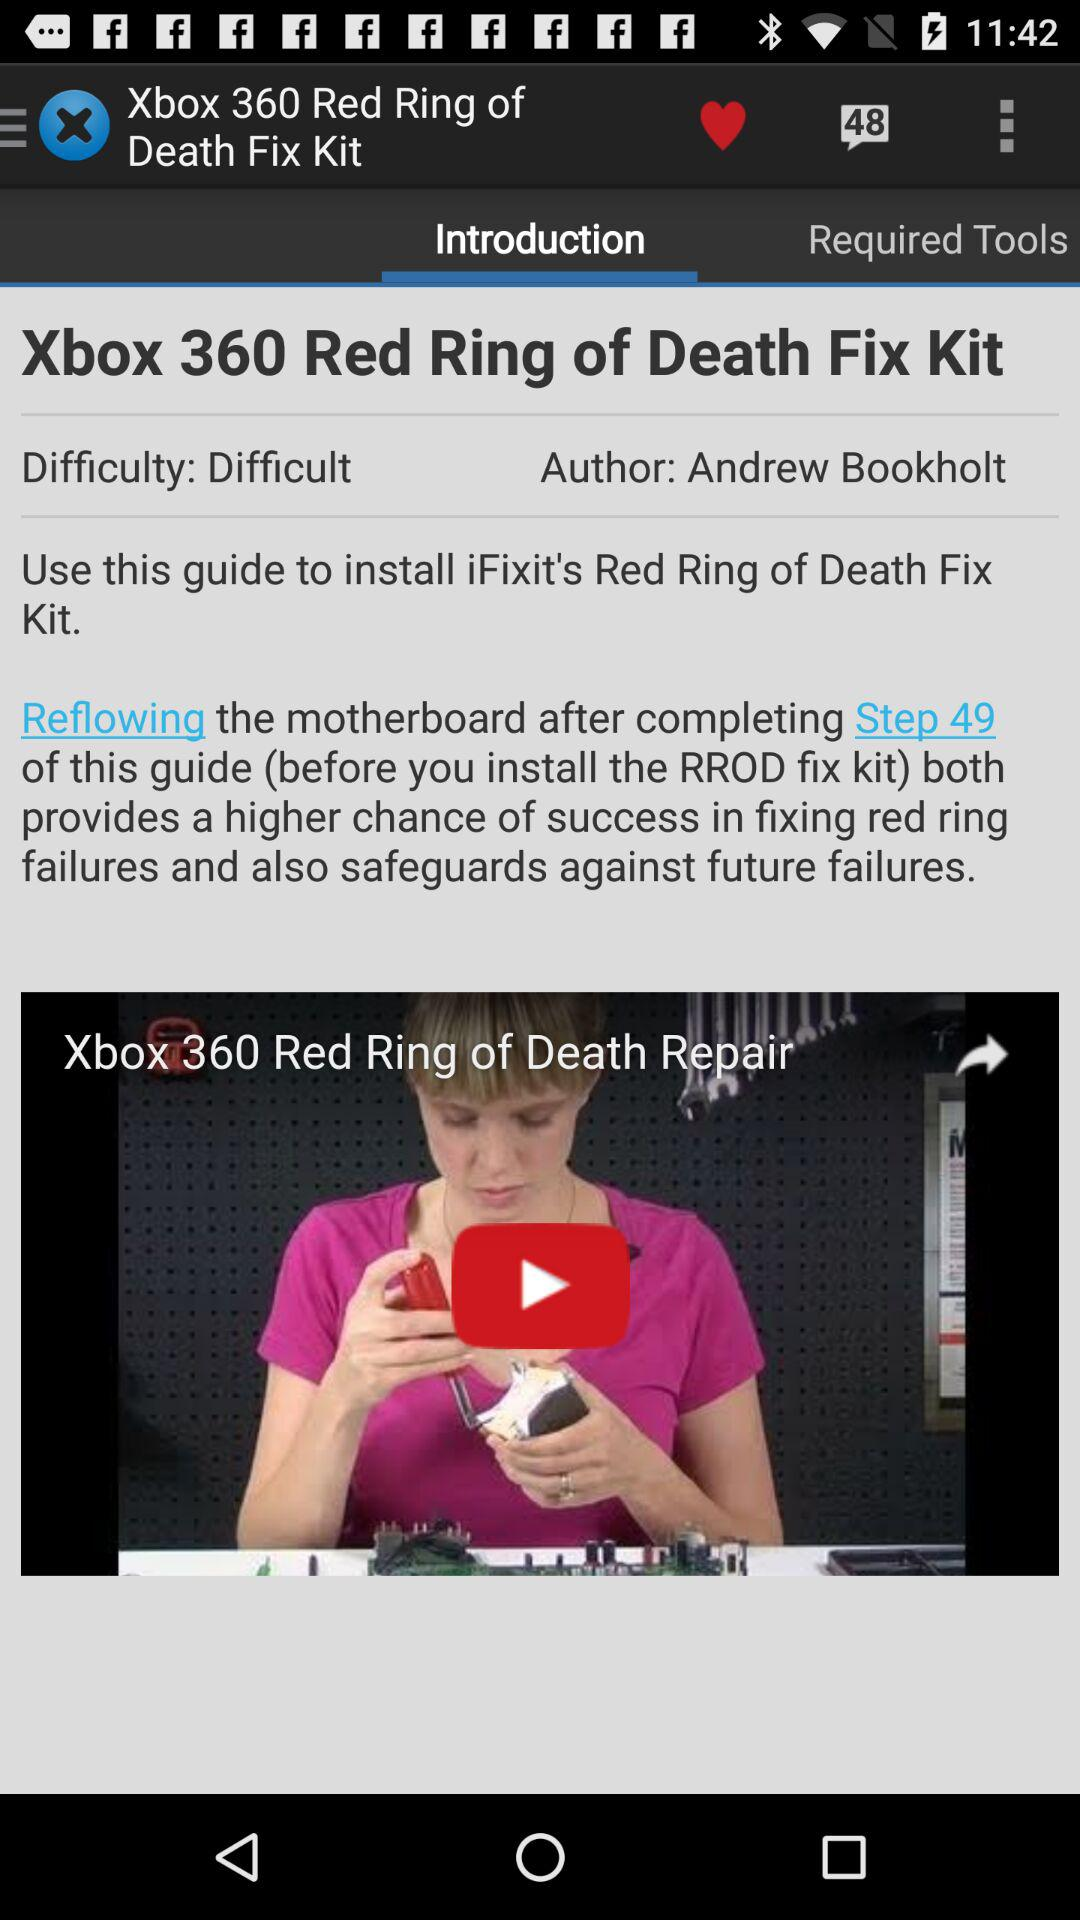What is the author's name? The author's name is Andrew Bookholt. 